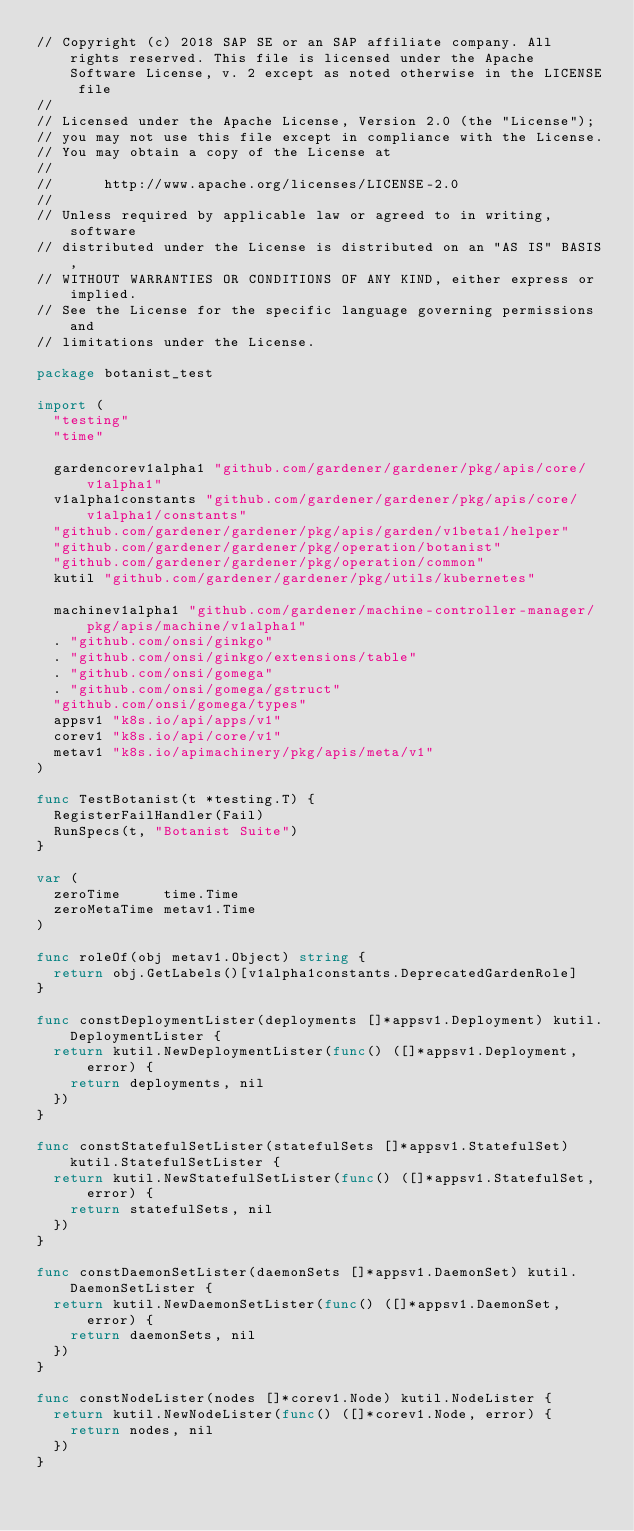Convert code to text. <code><loc_0><loc_0><loc_500><loc_500><_Go_>// Copyright (c) 2018 SAP SE or an SAP affiliate company. All rights reserved. This file is licensed under the Apache Software License, v. 2 except as noted otherwise in the LICENSE file
//
// Licensed under the Apache License, Version 2.0 (the "License");
// you may not use this file except in compliance with the License.
// You may obtain a copy of the License at
//
//      http://www.apache.org/licenses/LICENSE-2.0
//
// Unless required by applicable law or agreed to in writing, software
// distributed under the License is distributed on an "AS IS" BASIS,
// WITHOUT WARRANTIES OR CONDITIONS OF ANY KIND, either express or implied.
// See the License for the specific language governing permissions and
// limitations under the License.

package botanist_test

import (
	"testing"
	"time"

	gardencorev1alpha1 "github.com/gardener/gardener/pkg/apis/core/v1alpha1"
	v1alpha1constants "github.com/gardener/gardener/pkg/apis/core/v1alpha1/constants"
	"github.com/gardener/gardener/pkg/apis/garden/v1beta1/helper"
	"github.com/gardener/gardener/pkg/operation/botanist"
	"github.com/gardener/gardener/pkg/operation/common"
	kutil "github.com/gardener/gardener/pkg/utils/kubernetes"

	machinev1alpha1 "github.com/gardener/machine-controller-manager/pkg/apis/machine/v1alpha1"
	. "github.com/onsi/ginkgo"
	. "github.com/onsi/ginkgo/extensions/table"
	. "github.com/onsi/gomega"
	. "github.com/onsi/gomega/gstruct"
	"github.com/onsi/gomega/types"
	appsv1 "k8s.io/api/apps/v1"
	corev1 "k8s.io/api/core/v1"
	metav1 "k8s.io/apimachinery/pkg/apis/meta/v1"
)

func TestBotanist(t *testing.T) {
	RegisterFailHandler(Fail)
	RunSpecs(t, "Botanist Suite")
}

var (
	zeroTime     time.Time
	zeroMetaTime metav1.Time
)

func roleOf(obj metav1.Object) string {
	return obj.GetLabels()[v1alpha1constants.DeprecatedGardenRole]
}

func constDeploymentLister(deployments []*appsv1.Deployment) kutil.DeploymentLister {
	return kutil.NewDeploymentLister(func() ([]*appsv1.Deployment, error) {
		return deployments, nil
	})
}

func constStatefulSetLister(statefulSets []*appsv1.StatefulSet) kutil.StatefulSetLister {
	return kutil.NewStatefulSetLister(func() ([]*appsv1.StatefulSet, error) {
		return statefulSets, nil
	})
}

func constDaemonSetLister(daemonSets []*appsv1.DaemonSet) kutil.DaemonSetLister {
	return kutil.NewDaemonSetLister(func() ([]*appsv1.DaemonSet, error) {
		return daemonSets, nil
	})
}

func constNodeLister(nodes []*corev1.Node) kutil.NodeLister {
	return kutil.NewNodeLister(func() ([]*corev1.Node, error) {
		return nodes, nil
	})
}
</code> 